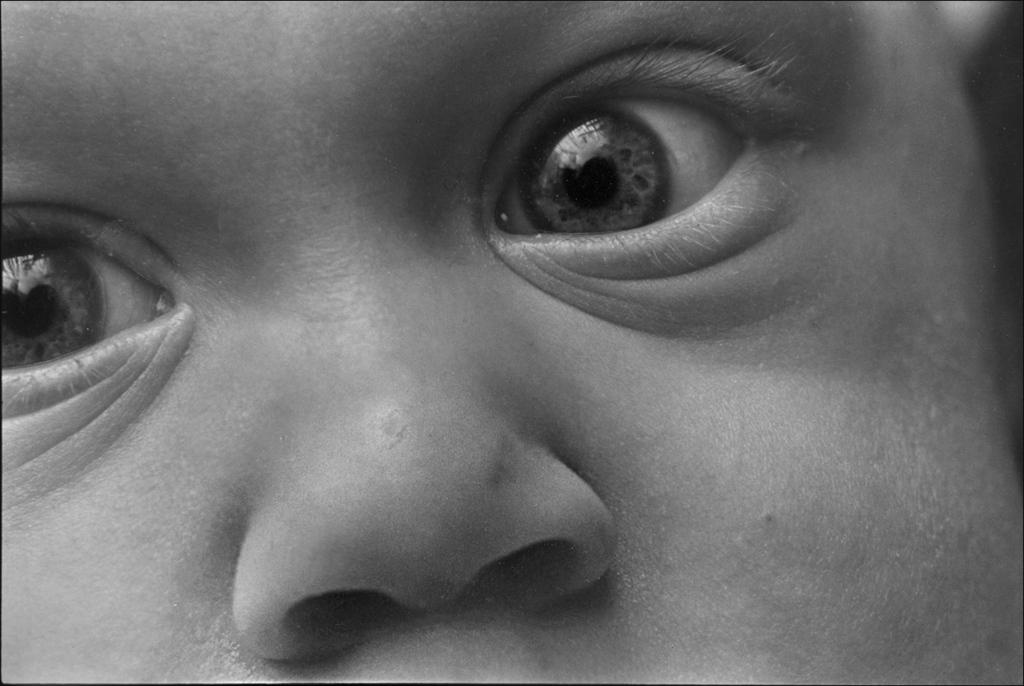What is the main subject of the image? There is a human face in the image. What facial features can be identified on the face? The face has eyes and a nose. What type of seed is being planted by the bears in the image? There are no bears or seeds present in the image; it features a human face with eyes and a nose. 